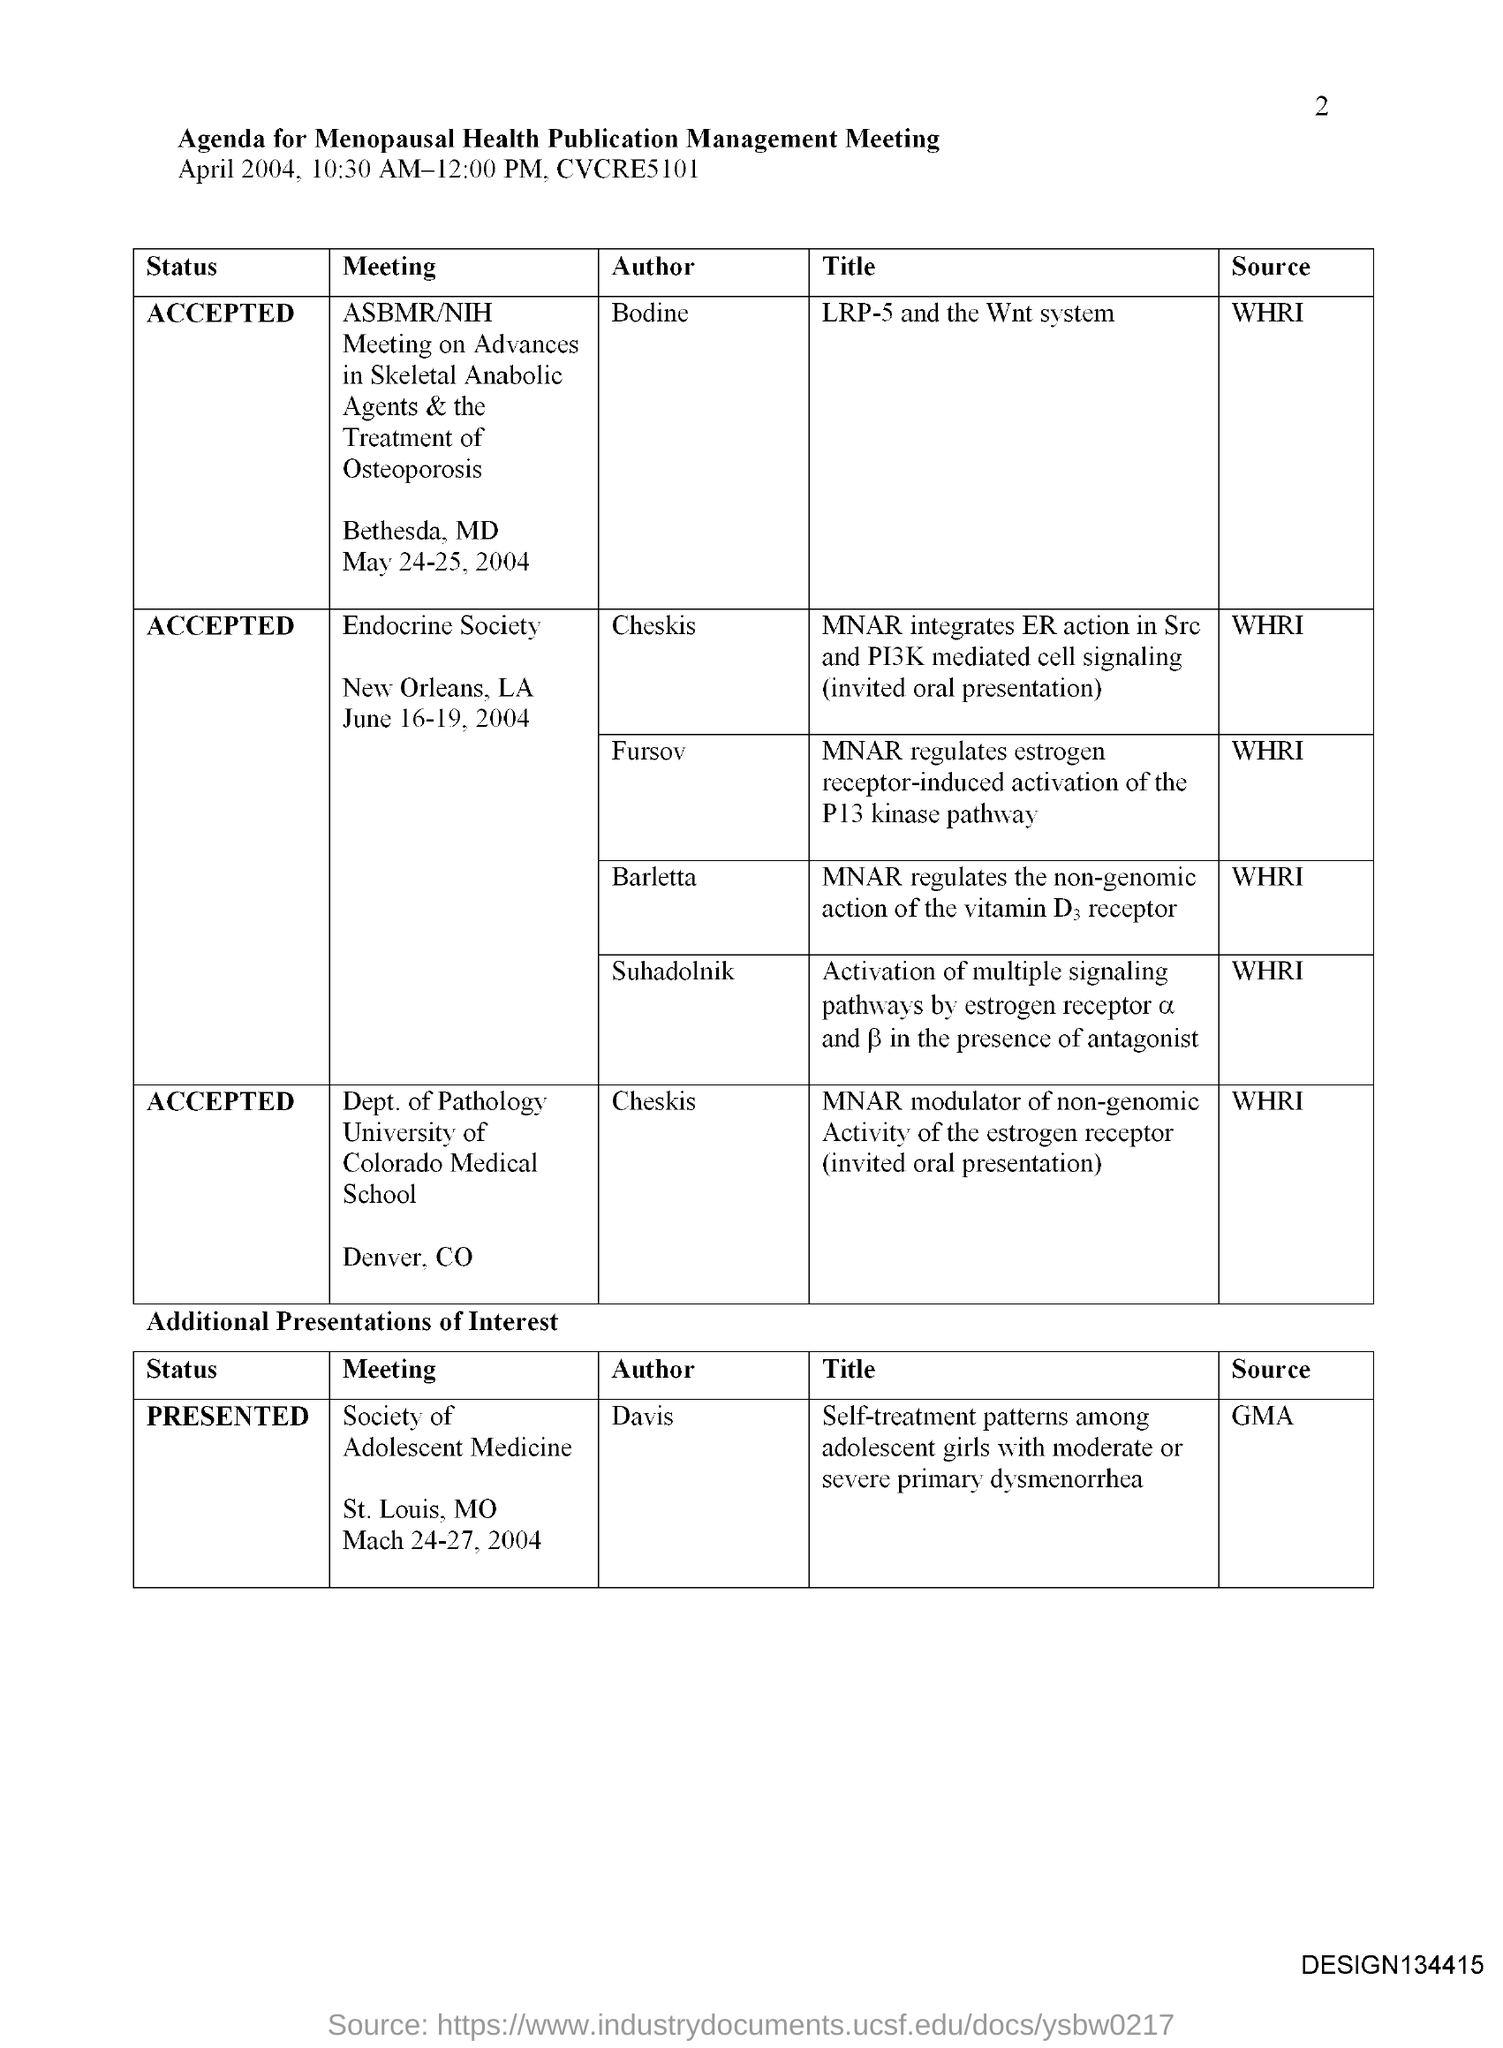What is the Page Number?
Your answer should be compact. 2. Who is the author of the meeting society of adolescent medicine?
Your answer should be very brief. Davis. 